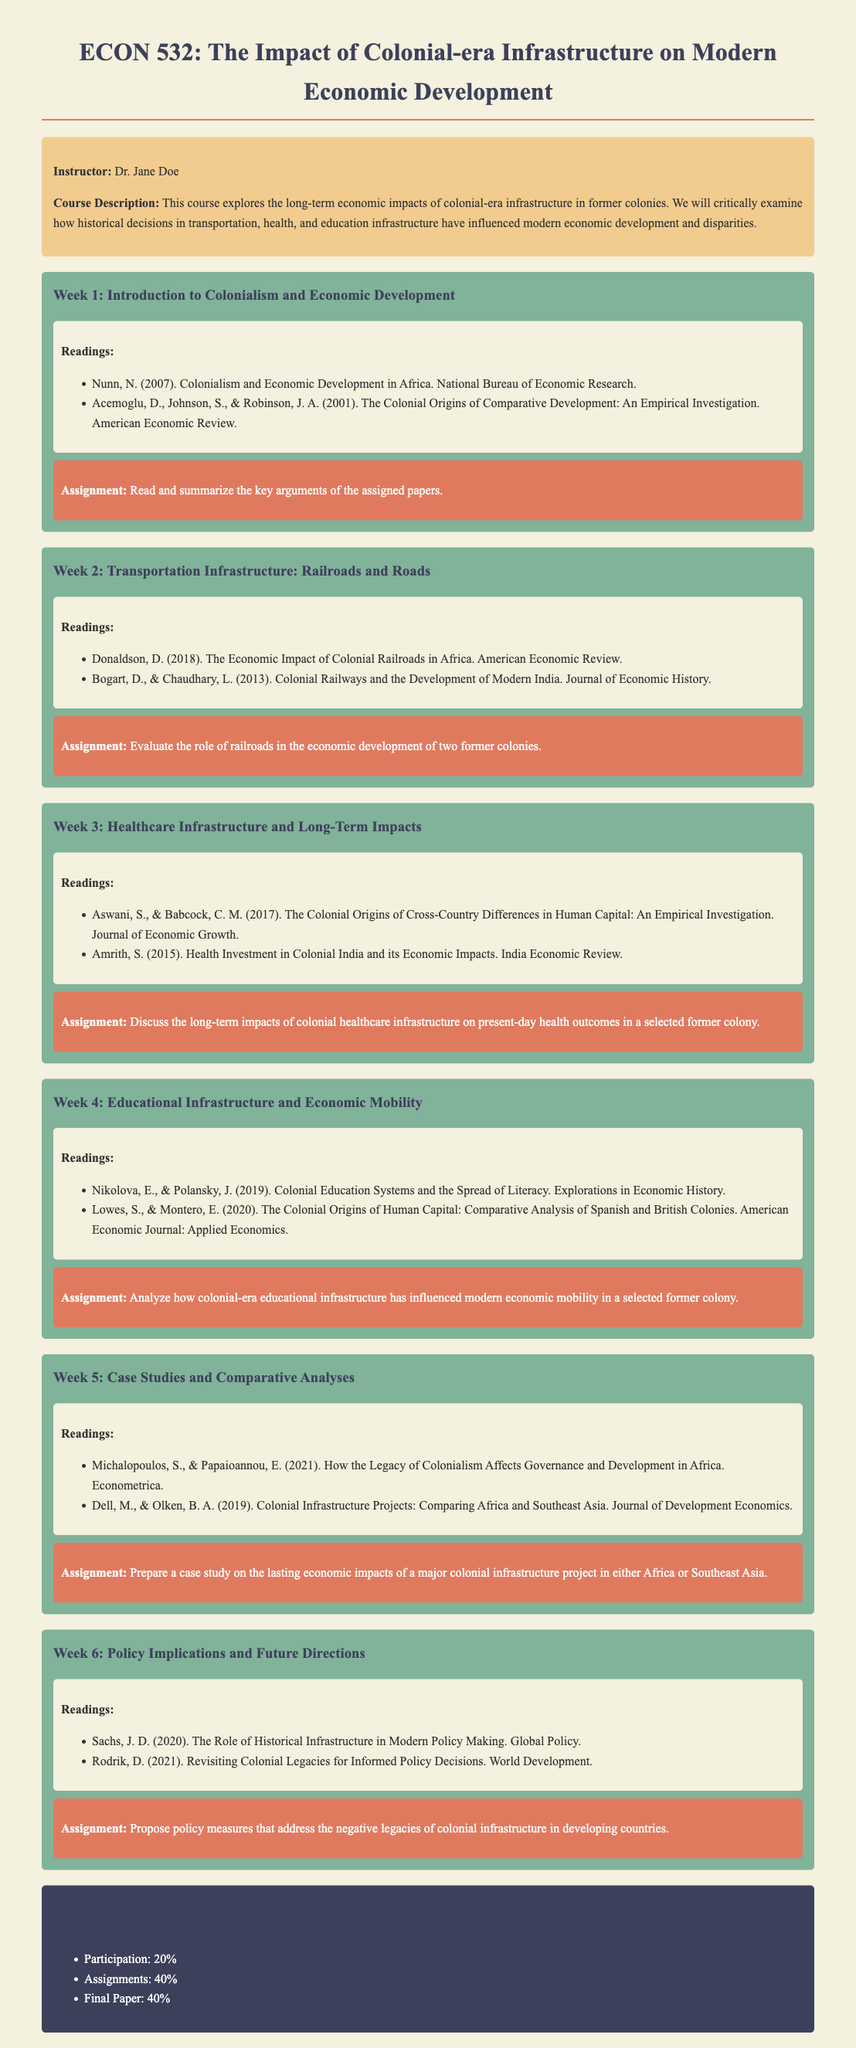What is the course title? The course title is listed prominently at the top of the document, making it easy to find.
Answer: The Impact of Colonial-era Infrastructure on Modern Economic Development Who is the instructor? The instructor's name is provided in the course information section.
Answer: Dr. Jane Doe What percentage of the grade does participation constitute? The grading section outlines the components of the course grading system, including participation.
Answer: 20% What is the focus of Week 3's readings? The readings for Week 3 focus on healthcare infrastructure and its long-term impacts.
Answer: Healthcare Infrastructure and Long-Term Impacts What is an assignment for Week 2? Each week includes a specific assignment and Week 2's assignment can be found in that section.
Answer: Evaluate the role of railroads in the economic development of two former colonies Which publication is associated with the topic of colonial education systems in Week 4? The readings list provides titles of papers relevant to the week's topic, including those on education systems.
Answer: Nikolova, E., & Polansky, J. (2019). Colonial Education Systems and the Spread of Literacy What does the course aim to critically examine? The course description highlights the goals and focuses of the class.
Answer: Historical decisions in transportation, health, and education infrastructure 